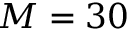<formula> <loc_0><loc_0><loc_500><loc_500>M = 3 0</formula> 